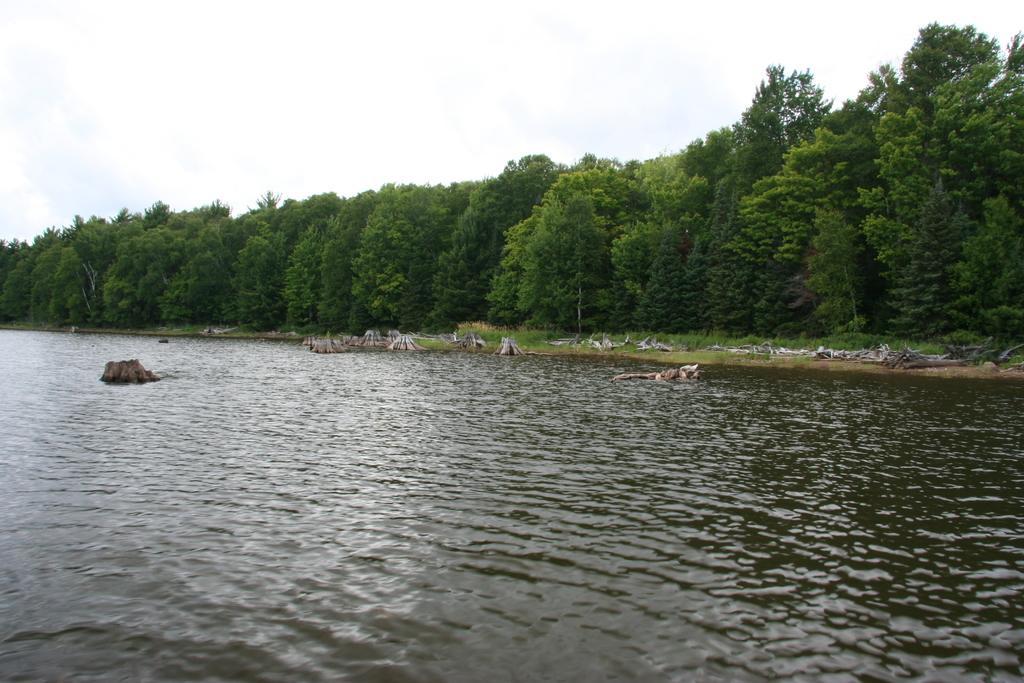How would you summarize this image in a sentence or two? In this image, we can see so many trees, plants, grass, some objects. At the bottom, there is a water. Top of the image, there is a sky. 